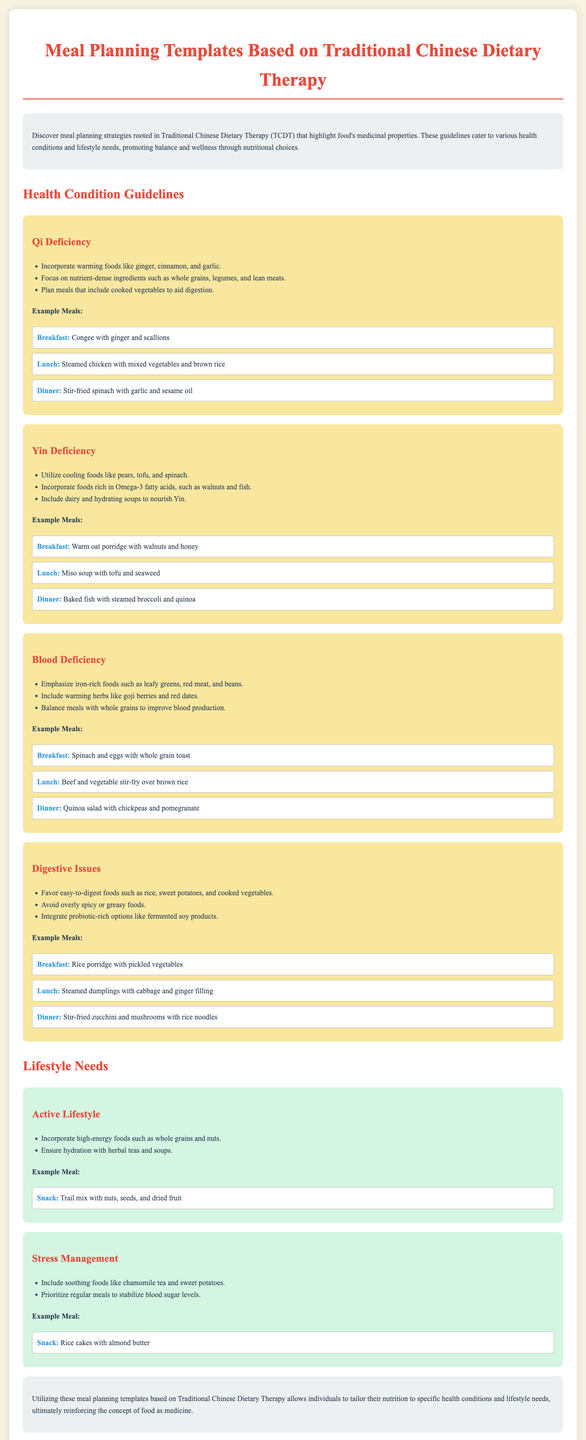What is Qi deficiency? Qi deficiency is a health condition that refers to a lack of vital energy in the body, which can lead to fatigue and weakness.
Answer: A health condition What should be included in meals for blood deficiency? Meals for blood deficiency should emphasize iron-rich foods such as leafy greens, red meat, and beans.
Answer: Iron-rich foods What is an example breakfast for Yin deficiency? The document provides specific meal examples that support Yin deficiency; one is warm oat porridge with walnuts and honey.
Answer: Warm oat porridge with walnuts and honey Which food group is recommended for an active lifestyle? The recommended food group for an active lifestyle includes high-energy foods such as whole grains and nuts.
Answer: High-energy foods What is a soothing food for stress management? Soothing foods for stress management include chamomile tea and sweet potatoes.
Answer: Chamomile tea What type of meal is suggested for someone with digestive issues? The meal suggestions for digestive issues highlight easy-to-digest foods like rice, sweet potatoes, and cooked vegetables.
Answer: Easy-to-digest foods What color background is used for health condition sections? The health condition sections have a yellow background color to distinguish them from other sections.
Answer: Yellow How many lifestyle needs are addressed in the document? The document outlines two lifestyle needs: active lifestyle and stress management.
Answer: Two 